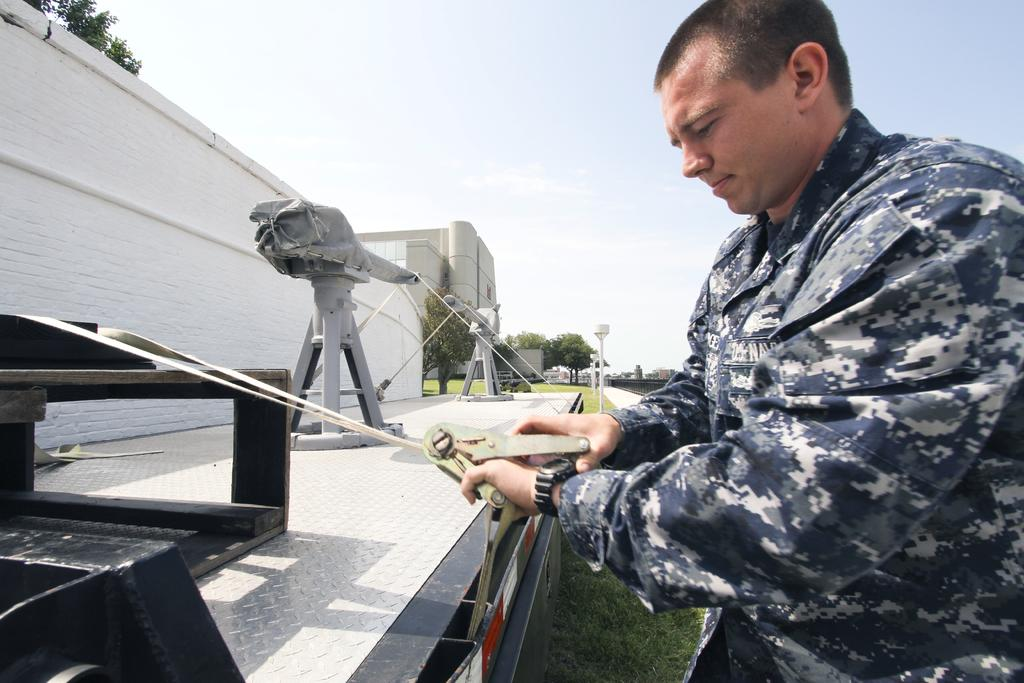What is present in the image? There is a person in the image. What is the person holding? The person is holding an object. Can you describe the objects in front of the person? There are objects in front of the person. What can be seen in the background of the image? There are trees, a building, poles, and the sky visible in the background of the image. What type of tank can be seen in the image? There is no tank present in the image. How does the person establish their territory in the image? The image does not depict any territorial behavior or markings, so it cannot be determined how the person establishes their territory. 